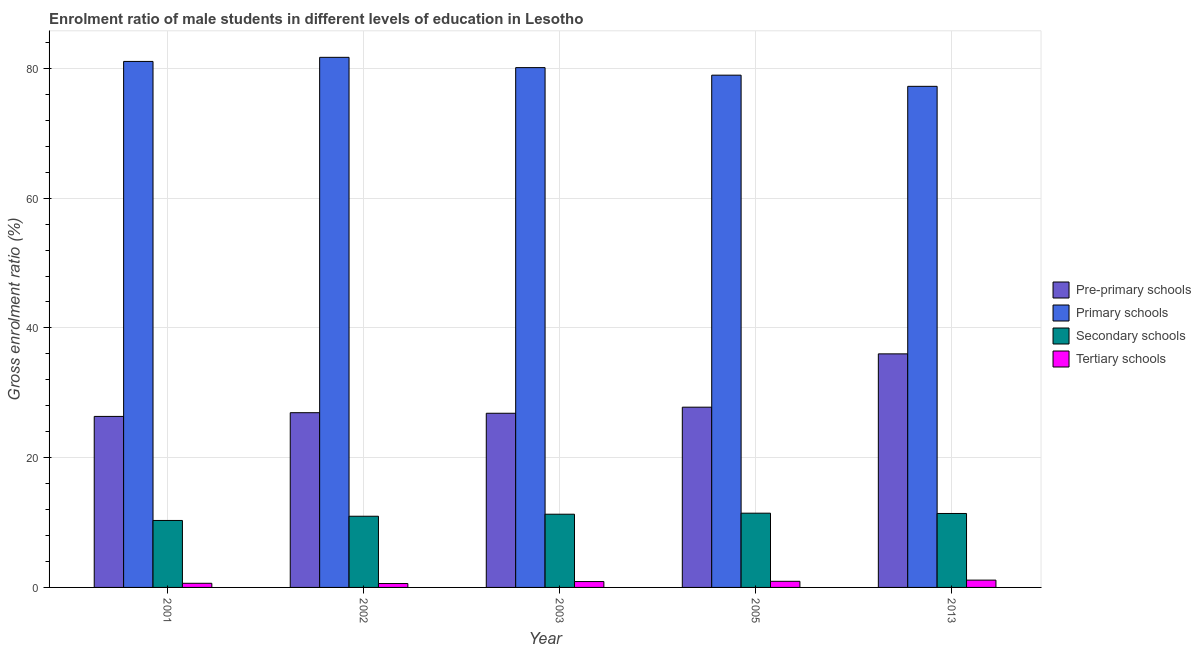What is the label of the 3rd group of bars from the left?
Your answer should be compact. 2003. In how many cases, is the number of bars for a given year not equal to the number of legend labels?
Provide a short and direct response. 0. What is the gross enrolment ratio(female) in secondary schools in 2013?
Offer a very short reply. 11.4. Across all years, what is the maximum gross enrolment ratio(female) in primary schools?
Offer a terse response. 81.7. Across all years, what is the minimum gross enrolment ratio(female) in pre-primary schools?
Your answer should be very brief. 26.36. What is the total gross enrolment ratio(female) in secondary schools in the graph?
Offer a very short reply. 55.42. What is the difference between the gross enrolment ratio(female) in secondary schools in 2001 and that in 2002?
Keep it short and to the point. -0.65. What is the difference between the gross enrolment ratio(female) in primary schools in 2013 and the gross enrolment ratio(female) in tertiary schools in 2003?
Offer a terse response. -2.88. What is the average gross enrolment ratio(female) in pre-primary schools per year?
Ensure brevity in your answer.  28.78. In the year 2002, what is the difference between the gross enrolment ratio(female) in primary schools and gross enrolment ratio(female) in tertiary schools?
Make the answer very short. 0. In how many years, is the gross enrolment ratio(female) in pre-primary schools greater than 80 %?
Your response must be concise. 0. What is the ratio of the gross enrolment ratio(female) in secondary schools in 2002 to that in 2013?
Ensure brevity in your answer.  0.96. Is the difference between the gross enrolment ratio(female) in pre-primary schools in 2001 and 2003 greater than the difference between the gross enrolment ratio(female) in primary schools in 2001 and 2003?
Give a very brief answer. No. What is the difference between the highest and the second highest gross enrolment ratio(female) in primary schools?
Your answer should be compact. 0.63. What is the difference between the highest and the lowest gross enrolment ratio(female) in primary schools?
Your answer should be compact. 4.47. In how many years, is the gross enrolment ratio(female) in pre-primary schools greater than the average gross enrolment ratio(female) in pre-primary schools taken over all years?
Make the answer very short. 1. Is it the case that in every year, the sum of the gross enrolment ratio(female) in pre-primary schools and gross enrolment ratio(female) in primary schools is greater than the sum of gross enrolment ratio(female) in tertiary schools and gross enrolment ratio(female) in secondary schools?
Make the answer very short. No. What does the 4th bar from the left in 2013 represents?
Provide a succinct answer. Tertiary schools. What does the 2nd bar from the right in 2013 represents?
Ensure brevity in your answer.  Secondary schools. How many years are there in the graph?
Your answer should be compact. 5. What is the difference between two consecutive major ticks on the Y-axis?
Give a very brief answer. 20. Are the values on the major ticks of Y-axis written in scientific E-notation?
Give a very brief answer. No. Does the graph contain grids?
Provide a short and direct response. Yes. Where does the legend appear in the graph?
Make the answer very short. Center right. How many legend labels are there?
Provide a succinct answer. 4. How are the legend labels stacked?
Make the answer very short. Vertical. What is the title of the graph?
Your response must be concise. Enrolment ratio of male students in different levels of education in Lesotho. What is the Gross enrolment ratio (%) of Pre-primary schools in 2001?
Your answer should be very brief. 26.36. What is the Gross enrolment ratio (%) of Primary schools in 2001?
Your answer should be very brief. 81.07. What is the Gross enrolment ratio (%) in Secondary schools in 2001?
Your response must be concise. 10.32. What is the Gross enrolment ratio (%) in Tertiary schools in 2001?
Your response must be concise. 0.64. What is the Gross enrolment ratio (%) of Pre-primary schools in 2002?
Give a very brief answer. 26.93. What is the Gross enrolment ratio (%) in Primary schools in 2002?
Offer a terse response. 81.7. What is the Gross enrolment ratio (%) of Secondary schools in 2002?
Your response must be concise. 10.97. What is the Gross enrolment ratio (%) of Tertiary schools in 2002?
Provide a succinct answer. 0.6. What is the Gross enrolment ratio (%) of Pre-primary schools in 2003?
Your response must be concise. 26.84. What is the Gross enrolment ratio (%) in Primary schools in 2003?
Ensure brevity in your answer.  80.12. What is the Gross enrolment ratio (%) in Secondary schools in 2003?
Provide a short and direct response. 11.28. What is the Gross enrolment ratio (%) in Tertiary schools in 2003?
Offer a very short reply. 0.91. What is the Gross enrolment ratio (%) of Pre-primary schools in 2005?
Give a very brief answer. 27.78. What is the Gross enrolment ratio (%) of Primary schools in 2005?
Keep it short and to the point. 78.96. What is the Gross enrolment ratio (%) of Secondary schools in 2005?
Ensure brevity in your answer.  11.44. What is the Gross enrolment ratio (%) in Tertiary schools in 2005?
Provide a succinct answer. 0.94. What is the Gross enrolment ratio (%) in Pre-primary schools in 2013?
Offer a very short reply. 36. What is the Gross enrolment ratio (%) in Primary schools in 2013?
Your answer should be compact. 77.23. What is the Gross enrolment ratio (%) of Secondary schools in 2013?
Offer a terse response. 11.4. What is the Gross enrolment ratio (%) in Tertiary schools in 2013?
Offer a terse response. 1.13. Across all years, what is the maximum Gross enrolment ratio (%) of Pre-primary schools?
Keep it short and to the point. 36. Across all years, what is the maximum Gross enrolment ratio (%) of Primary schools?
Provide a short and direct response. 81.7. Across all years, what is the maximum Gross enrolment ratio (%) of Secondary schools?
Keep it short and to the point. 11.44. Across all years, what is the maximum Gross enrolment ratio (%) of Tertiary schools?
Make the answer very short. 1.13. Across all years, what is the minimum Gross enrolment ratio (%) in Pre-primary schools?
Your answer should be compact. 26.36. Across all years, what is the minimum Gross enrolment ratio (%) in Primary schools?
Provide a short and direct response. 77.23. Across all years, what is the minimum Gross enrolment ratio (%) in Secondary schools?
Offer a very short reply. 10.32. Across all years, what is the minimum Gross enrolment ratio (%) of Tertiary schools?
Keep it short and to the point. 0.6. What is the total Gross enrolment ratio (%) in Pre-primary schools in the graph?
Your answer should be very brief. 143.91. What is the total Gross enrolment ratio (%) in Primary schools in the graph?
Your response must be concise. 399.09. What is the total Gross enrolment ratio (%) of Secondary schools in the graph?
Offer a terse response. 55.42. What is the total Gross enrolment ratio (%) of Tertiary schools in the graph?
Your answer should be very brief. 4.21. What is the difference between the Gross enrolment ratio (%) of Pre-primary schools in 2001 and that in 2002?
Give a very brief answer. -0.57. What is the difference between the Gross enrolment ratio (%) in Primary schools in 2001 and that in 2002?
Your response must be concise. -0.63. What is the difference between the Gross enrolment ratio (%) in Secondary schools in 2001 and that in 2002?
Your response must be concise. -0.65. What is the difference between the Gross enrolment ratio (%) of Tertiary schools in 2001 and that in 2002?
Provide a short and direct response. 0.04. What is the difference between the Gross enrolment ratio (%) in Pre-primary schools in 2001 and that in 2003?
Provide a succinct answer. -0.49. What is the difference between the Gross enrolment ratio (%) in Primary schools in 2001 and that in 2003?
Give a very brief answer. 0.95. What is the difference between the Gross enrolment ratio (%) of Secondary schools in 2001 and that in 2003?
Offer a very short reply. -0.96. What is the difference between the Gross enrolment ratio (%) of Tertiary schools in 2001 and that in 2003?
Your answer should be very brief. -0.27. What is the difference between the Gross enrolment ratio (%) of Pre-primary schools in 2001 and that in 2005?
Ensure brevity in your answer.  -1.42. What is the difference between the Gross enrolment ratio (%) of Primary schools in 2001 and that in 2005?
Your response must be concise. 2.12. What is the difference between the Gross enrolment ratio (%) in Secondary schools in 2001 and that in 2005?
Give a very brief answer. -1.12. What is the difference between the Gross enrolment ratio (%) of Tertiary schools in 2001 and that in 2005?
Give a very brief answer. -0.31. What is the difference between the Gross enrolment ratio (%) in Pre-primary schools in 2001 and that in 2013?
Your response must be concise. -9.64. What is the difference between the Gross enrolment ratio (%) of Primary schools in 2001 and that in 2013?
Your answer should be compact. 3.84. What is the difference between the Gross enrolment ratio (%) of Secondary schools in 2001 and that in 2013?
Provide a succinct answer. -1.08. What is the difference between the Gross enrolment ratio (%) in Tertiary schools in 2001 and that in 2013?
Provide a succinct answer. -0.49. What is the difference between the Gross enrolment ratio (%) of Pre-primary schools in 2002 and that in 2003?
Your answer should be very brief. 0.09. What is the difference between the Gross enrolment ratio (%) of Primary schools in 2002 and that in 2003?
Offer a very short reply. 1.59. What is the difference between the Gross enrolment ratio (%) of Secondary schools in 2002 and that in 2003?
Provide a succinct answer. -0.31. What is the difference between the Gross enrolment ratio (%) of Tertiary schools in 2002 and that in 2003?
Offer a very short reply. -0.3. What is the difference between the Gross enrolment ratio (%) in Pre-primary schools in 2002 and that in 2005?
Give a very brief answer. -0.85. What is the difference between the Gross enrolment ratio (%) of Primary schools in 2002 and that in 2005?
Offer a terse response. 2.75. What is the difference between the Gross enrolment ratio (%) in Secondary schools in 2002 and that in 2005?
Your answer should be very brief. -0.47. What is the difference between the Gross enrolment ratio (%) of Tertiary schools in 2002 and that in 2005?
Offer a very short reply. -0.34. What is the difference between the Gross enrolment ratio (%) in Pre-primary schools in 2002 and that in 2013?
Offer a terse response. -9.07. What is the difference between the Gross enrolment ratio (%) of Primary schools in 2002 and that in 2013?
Offer a terse response. 4.47. What is the difference between the Gross enrolment ratio (%) in Secondary schools in 2002 and that in 2013?
Offer a terse response. -0.43. What is the difference between the Gross enrolment ratio (%) in Tertiary schools in 2002 and that in 2013?
Offer a very short reply. -0.53. What is the difference between the Gross enrolment ratio (%) in Pre-primary schools in 2003 and that in 2005?
Offer a terse response. -0.94. What is the difference between the Gross enrolment ratio (%) of Primary schools in 2003 and that in 2005?
Give a very brief answer. 1.16. What is the difference between the Gross enrolment ratio (%) in Secondary schools in 2003 and that in 2005?
Ensure brevity in your answer.  -0.16. What is the difference between the Gross enrolment ratio (%) of Tertiary schools in 2003 and that in 2005?
Your response must be concise. -0.04. What is the difference between the Gross enrolment ratio (%) of Pre-primary schools in 2003 and that in 2013?
Offer a very short reply. -9.16. What is the difference between the Gross enrolment ratio (%) of Primary schools in 2003 and that in 2013?
Offer a terse response. 2.88. What is the difference between the Gross enrolment ratio (%) of Secondary schools in 2003 and that in 2013?
Your answer should be compact. -0.11. What is the difference between the Gross enrolment ratio (%) in Tertiary schools in 2003 and that in 2013?
Ensure brevity in your answer.  -0.22. What is the difference between the Gross enrolment ratio (%) of Pre-primary schools in 2005 and that in 2013?
Make the answer very short. -8.22. What is the difference between the Gross enrolment ratio (%) of Primary schools in 2005 and that in 2013?
Your response must be concise. 1.72. What is the difference between the Gross enrolment ratio (%) in Secondary schools in 2005 and that in 2013?
Give a very brief answer. 0.05. What is the difference between the Gross enrolment ratio (%) of Tertiary schools in 2005 and that in 2013?
Provide a short and direct response. -0.18. What is the difference between the Gross enrolment ratio (%) of Pre-primary schools in 2001 and the Gross enrolment ratio (%) of Primary schools in 2002?
Your answer should be compact. -55.35. What is the difference between the Gross enrolment ratio (%) of Pre-primary schools in 2001 and the Gross enrolment ratio (%) of Secondary schools in 2002?
Keep it short and to the point. 15.39. What is the difference between the Gross enrolment ratio (%) of Pre-primary schools in 2001 and the Gross enrolment ratio (%) of Tertiary schools in 2002?
Provide a succinct answer. 25.76. What is the difference between the Gross enrolment ratio (%) in Primary schools in 2001 and the Gross enrolment ratio (%) in Secondary schools in 2002?
Provide a short and direct response. 70.1. What is the difference between the Gross enrolment ratio (%) in Primary schools in 2001 and the Gross enrolment ratio (%) in Tertiary schools in 2002?
Ensure brevity in your answer.  80.47. What is the difference between the Gross enrolment ratio (%) of Secondary schools in 2001 and the Gross enrolment ratio (%) of Tertiary schools in 2002?
Your answer should be very brief. 9.72. What is the difference between the Gross enrolment ratio (%) in Pre-primary schools in 2001 and the Gross enrolment ratio (%) in Primary schools in 2003?
Your response must be concise. -53.76. What is the difference between the Gross enrolment ratio (%) in Pre-primary schools in 2001 and the Gross enrolment ratio (%) in Secondary schools in 2003?
Offer a very short reply. 15.07. What is the difference between the Gross enrolment ratio (%) of Pre-primary schools in 2001 and the Gross enrolment ratio (%) of Tertiary schools in 2003?
Provide a succinct answer. 25.45. What is the difference between the Gross enrolment ratio (%) of Primary schools in 2001 and the Gross enrolment ratio (%) of Secondary schools in 2003?
Your response must be concise. 69.79. What is the difference between the Gross enrolment ratio (%) of Primary schools in 2001 and the Gross enrolment ratio (%) of Tertiary schools in 2003?
Keep it short and to the point. 80.17. What is the difference between the Gross enrolment ratio (%) of Secondary schools in 2001 and the Gross enrolment ratio (%) of Tertiary schools in 2003?
Make the answer very short. 9.42. What is the difference between the Gross enrolment ratio (%) of Pre-primary schools in 2001 and the Gross enrolment ratio (%) of Primary schools in 2005?
Your response must be concise. -52.6. What is the difference between the Gross enrolment ratio (%) in Pre-primary schools in 2001 and the Gross enrolment ratio (%) in Secondary schools in 2005?
Keep it short and to the point. 14.91. What is the difference between the Gross enrolment ratio (%) of Pre-primary schools in 2001 and the Gross enrolment ratio (%) of Tertiary schools in 2005?
Offer a very short reply. 25.41. What is the difference between the Gross enrolment ratio (%) in Primary schools in 2001 and the Gross enrolment ratio (%) in Secondary schools in 2005?
Provide a succinct answer. 69.63. What is the difference between the Gross enrolment ratio (%) in Primary schools in 2001 and the Gross enrolment ratio (%) in Tertiary schools in 2005?
Give a very brief answer. 80.13. What is the difference between the Gross enrolment ratio (%) in Secondary schools in 2001 and the Gross enrolment ratio (%) in Tertiary schools in 2005?
Give a very brief answer. 9.38. What is the difference between the Gross enrolment ratio (%) of Pre-primary schools in 2001 and the Gross enrolment ratio (%) of Primary schools in 2013?
Your answer should be very brief. -50.88. What is the difference between the Gross enrolment ratio (%) in Pre-primary schools in 2001 and the Gross enrolment ratio (%) in Secondary schools in 2013?
Your answer should be compact. 14.96. What is the difference between the Gross enrolment ratio (%) of Pre-primary schools in 2001 and the Gross enrolment ratio (%) of Tertiary schools in 2013?
Offer a very short reply. 25.23. What is the difference between the Gross enrolment ratio (%) of Primary schools in 2001 and the Gross enrolment ratio (%) of Secondary schools in 2013?
Give a very brief answer. 69.67. What is the difference between the Gross enrolment ratio (%) in Primary schools in 2001 and the Gross enrolment ratio (%) in Tertiary schools in 2013?
Your answer should be compact. 79.94. What is the difference between the Gross enrolment ratio (%) in Secondary schools in 2001 and the Gross enrolment ratio (%) in Tertiary schools in 2013?
Offer a very short reply. 9.19. What is the difference between the Gross enrolment ratio (%) in Pre-primary schools in 2002 and the Gross enrolment ratio (%) in Primary schools in 2003?
Provide a succinct answer. -53.19. What is the difference between the Gross enrolment ratio (%) in Pre-primary schools in 2002 and the Gross enrolment ratio (%) in Secondary schools in 2003?
Provide a succinct answer. 15.65. What is the difference between the Gross enrolment ratio (%) in Pre-primary schools in 2002 and the Gross enrolment ratio (%) in Tertiary schools in 2003?
Offer a terse response. 26.03. What is the difference between the Gross enrolment ratio (%) of Primary schools in 2002 and the Gross enrolment ratio (%) of Secondary schools in 2003?
Provide a short and direct response. 70.42. What is the difference between the Gross enrolment ratio (%) in Primary schools in 2002 and the Gross enrolment ratio (%) in Tertiary schools in 2003?
Your answer should be very brief. 80.8. What is the difference between the Gross enrolment ratio (%) in Secondary schools in 2002 and the Gross enrolment ratio (%) in Tertiary schools in 2003?
Offer a very short reply. 10.07. What is the difference between the Gross enrolment ratio (%) of Pre-primary schools in 2002 and the Gross enrolment ratio (%) of Primary schools in 2005?
Offer a terse response. -52.03. What is the difference between the Gross enrolment ratio (%) of Pre-primary schools in 2002 and the Gross enrolment ratio (%) of Secondary schools in 2005?
Make the answer very short. 15.49. What is the difference between the Gross enrolment ratio (%) in Pre-primary schools in 2002 and the Gross enrolment ratio (%) in Tertiary schools in 2005?
Provide a short and direct response. 25.99. What is the difference between the Gross enrolment ratio (%) in Primary schools in 2002 and the Gross enrolment ratio (%) in Secondary schools in 2005?
Offer a terse response. 70.26. What is the difference between the Gross enrolment ratio (%) in Primary schools in 2002 and the Gross enrolment ratio (%) in Tertiary schools in 2005?
Keep it short and to the point. 80.76. What is the difference between the Gross enrolment ratio (%) in Secondary schools in 2002 and the Gross enrolment ratio (%) in Tertiary schools in 2005?
Offer a very short reply. 10.03. What is the difference between the Gross enrolment ratio (%) of Pre-primary schools in 2002 and the Gross enrolment ratio (%) of Primary schools in 2013?
Your answer should be compact. -50.3. What is the difference between the Gross enrolment ratio (%) of Pre-primary schools in 2002 and the Gross enrolment ratio (%) of Secondary schools in 2013?
Your answer should be compact. 15.53. What is the difference between the Gross enrolment ratio (%) of Pre-primary schools in 2002 and the Gross enrolment ratio (%) of Tertiary schools in 2013?
Keep it short and to the point. 25.8. What is the difference between the Gross enrolment ratio (%) in Primary schools in 2002 and the Gross enrolment ratio (%) in Secondary schools in 2013?
Provide a succinct answer. 70.31. What is the difference between the Gross enrolment ratio (%) of Primary schools in 2002 and the Gross enrolment ratio (%) of Tertiary schools in 2013?
Your response must be concise. 80.58. What is the difference between the Gross enrolment ratio (%) of Secondary schools in 2002 and the Gross enrolment ratio (%) of Tertiary schools in 2013?
Give a very brief answer. 9.84. What is the difference between the Gross enrolment ratio (%) of Pre-primary schools in 2003 and the Gross enrolment ratio (%) of Primary schools in 2005?
Make the answer very short. -52.11. What is the difference between the Gross enrolment ratio (%) of Pre-primary schools in 2003 and the Gross enrolment ratio (%) of Secondary schools in 2005?
Make the answer very short. 15.4. What is the difference between the Gross enrolment ratio (%) in Pre-primary schools in 2003 and the Gross enrolment ratio (%) in Tertiary schools in 2005?
Your answer should be compact. 25.9. What is the difference between the Gross enrolment ratio (%) in Primary schools in 2003 and the Gross enrolment ratio (%) in Secondary schools in 2005?
Your response must be concise. 68.67. What is the difference between the Gross enrolment ratio (%) in Primary schools in 2003 and the Gross enrolment ratio (%) in Tertiary schools in 2005?
Provide a succinct answer. 79.17. What is the difference between the Gross enrolment ratio (%) of Secondary schools in 2003 and the Gross enrolment ratio (%) of Tertiary schools in 2005?
Give a very brief answer. 10.34. What is the difference between the Gross enrolment ratio (%) in Pre-primary schools in 2003 and the Gross enrolment ratio (%) in Primary schools in 2013?
Give a very brief answer. -50.39. What is the difference between the Gross enrolment ratio (%) of Pre-primary schools in 2003 and the Gross enrolment ratio (%) of Secondary schools in 2013?
Provide a succinct answer. 15.45. What is the difference between the Gross enrolment ratio (%) in Pre-primary schools in 2003 and the Gross enrolment ratio (%) in Tertiary schools in 2013?
Give a very brief answer. 25.72. What is the difference between the Gross enrolment ratio (%) in Primary schools in 2003 and the Gross enrolment ratio (%) in Secondary schools in 2013?
Ensure brevity in your answer.  68.72. What is the difference between the Gross enrolment ratio (%) in Primary schools in 2003 and the Gross enrolment ratio (%) in Tertiary schools in 2013?
Keep it short and to the point. 78.99. What is the difference between the Gross enrolment ratio (%) in Secondary schools in 2003 and the Gross enrolment ratio (%) in Tertiary schools in 2013?
Offer a terse response. 10.16. What is the difference between the Gross enrolment ratio (%) of Pre-primary schools in 2005 and the Gross enrolment ratio (%) of Primary schools in 2013?
Offer a very short reply. -49.45. What is the difference between the Gross enrolment ratio (%) of Pre-primary schools in 2005 and the Gross enrolment ratio (%) of Secondary schools in 2013?
Offer a very short reply. 16.38. What is the difference between the Gross enrolment ratio (%) of Pre-primary schools in 2005 and the Gross enrolment ratio (%) of Tertiary schools in 2013?
Offer a very short reply. 26.65. What is the difference between the Gross enrolment ratio (%) in Primary schools in 2005 and the Gross enrolment ratio (%) in Secondary schools in 2013?
Provide a succinct answer. 67.56. What is the difference between the Gross enrolment ratio (%) in Primary schools in 2005 and the Gross enrolment ratio (%) in Tertiary schools in 2013?
Ensure brevity in your answer.  77.83. What is the difference between the Gross enrolment ratio (%) of Secondary schools in 2005 and the Gross enrolment ratio (%) of Tertiary schools in 2013?
Your response must be concise. 10.32. What is the average Gross enrolment ratio (%) in Pre-primary schools per year?
Give a very brief answer. 28.78. What is the average Gross enrolment ratio (%) of Primary schools per year?
Provide a short and direct response. 79.82. What is the average Gross enrolment ratio (%) of Secondary schools per year?
Ensure brevity in your answer.  11.08. What is the average Gross enrolment ratio (%) of Tertiary schools per year?
Ensure brevity in your answer.  0.84. In the year 2001, what is the difference between the Gross enrolment ratio (%) of Pre-primary schools and Gross enrolment ratio (%) of Primary schools?
Your answer should be compact. -54.71. In the year 2001, what is the difference between the Gross enrolment ratio (%) of Pre-primary schools and Gross enrolment ratio (%) of Secondary schools?
Offer a very short reply. 16.04. In the year 2001, what is the difference between the Gross enrolment ratio (%) of Pre-primary schools and Gross enrolment ratio (%) of Tertiary schools?
Your answer should be very brief. 25.72. In the year 2001, what is the difference between the Gross enrolment ratio (%) of Primary schools and Gross enrolment ratio (%) of Secondary schools?
Provide a succinct answer. 70.75. In the year 2001, what is the difference between the Gross enrolment ratio (%) of Primary schools and Gross enrolment ratio (%) of Tertiary schools?
Your response must be concise. 80.44. In the year 2001, what is the difference between the Gross enrolment ratio (%) of Secondary schools and Gross enrolment ratio (%) of Tertiary schools?
Ensure brevity in your answer.  9.69. In the year 2002, what is the difference between the Gross enrolment ratio (%) in Pre-primary schools and Gross enrolment ratio (%) in Primary schools?
Ensure brevity in your answer.  -54.77. In the year 2002, what is the difference between the Gross enrolment ratio (%) in Pre-primary schools and Gross enrolment ratio (%) in Secondary schools?
Your answer should be very brief. 15.96. In the year 2002, what is the difference between the Gross enrolment ratio (%) of Pre-primary schools and Gross enrolment ratio (%) of Tertiary schools?
Your answer should be compact. 26.33. In the year 2002, what is the difference between the Gross enrolment ratio (%) of Primary schools and Gross enrolment ratio (%) of Secondary schools?
Your response must be concise. 70.73. In the year 2002, what is the difference between the Gross enrolment ratio (%) of Primary schools and Gross enrolment ratio (%) of Tertiary schools?
Your response must be concise. 81.1. In the year 2002, what is the difference between the Gross enrolment ratio (%) of Secondary schools and Gross enrolment ratio (%) of Tertiary schools?
Your answer should be very brief. 10.37. In the year 2003, what is the difference between the Gross enrolment ratio (%) in Pre-primary schools and Gross enrolment ratio (%) in Primary schools?
Keep it short and to the point. -53.27. In the year 2003, what is the difference between the Gross enrolment ratio (%) in Pre-primary schools and Gross enrolment ratio (%) in Secondary schools?
Offer a very short reply. 15.56. In the year 2003, what is the difference between the Gross enrolment ratio (%) in Pre-primary schools and Gross enrolment ratio (%) in Tertiary schools?
Your answer should be compact. 25.94. In the year 2003, what is the difference between the Gross enrolment ratio (%) of Primary schools and Gross enrolment ratio (%) of Secondary schools?
Keep it short and to the point. 68.83. In the year 2003, what is the difference between the Gross enrolment ratio (%) in Primary schools and Gross enrolment ratio (%) in Tertiary schools?
Ensure brevity in your answer.  79.21. In the year 2003, what is the difference between the Gross enrolment ratio (%) in Secondary schools and Gross enrolment ratio (%) in Tertiary schools?
Provide a short and direct response. 10.38. In the year 2005, what is the difference between the Gross enrolment ratio (%) in Pre-primary schools and Gross enrolment ratio (%) in Primary schools?
Your answer should be very brief. -51.18. In the year 2005, what is the difference between the Gross enrolment ratio (%) in Pre-primary schools and Gross enrolment ratio (%) in Secondary schools?
Provide a short and direct response. 16.34. In the year 2005, what is the difference between the Gross enrolment ratio (%) in Pre-primary schools and Gross enrolment ratio (%) in Tertiary schools?
Your answer should be compact. 26.84. In the year 2005, what is the difference between the Gross enrolment ratio (%) in Primary schools and Gross enrolment ratio (%) in Secondary schools?
Provide a succinct answer. 67.51. In the year 2005, what is the difference between the Gross enrolment ratio (%) of Primary schools and Gross enrolment ratio (%) of Tertiary schools?
Your answer should be very brief. 78.01. In the year 2005, what is the difference between the Gross enrolment ratio (%) in Secondary schools and Gross enrolment ratio (%) in Tertiary schools?
Provide a short and direct response. 10.5. In the year 2013, what is the difference between the Gross enrolment ratio (%) in Pre-primary schools and Gross enrolment ratio (%) in Primary schools?
Provide a short and direct response. -41.23. In the year 2013, what is the difference between the Gross enrolment ratio (%) of Pre-primary schools and Gross enrolment ratio (%) of Secondary schools?
Offer a terse response. 24.6. In the year 2013, what is the difference between the Gross enrolment ratio (%) in Pre-primary schools and Gross enrolment ratio (%) in Tertiary schools?
Provide a short and direct response. 34.87. In the year 2013, what is the difference between the Gross enrolment ratio (%) of Primary schools and Gross enrolment ratio (%) of Secondary schools?
Provide a succinct answer. 65.84. In the year 2013, what is the difference between the Gross enrolment ratio (%) of Primary schools and Gross enrolment ratio (%) of Tertiary schools?
Provide a short and direct response. 76.11. In the year 2013, what is the difference between the Gross enrolment ratio (%) in Secondary schools and Gross enrolment ratio (%) in Tertiary schools?
Give a very brief answer. 10.27. What is the ratio of the Gross enrolment ratio (%) of Pre-primary schools in 2001 to that in 2002?
Keep it short and to the point. 0.98. What is the ratio of the Gross enrolment ratio (%) of Secondary schools in 2001 to that in 2002?
Offer a terse response. 0.94. What is the ratio of the Gross enrolment ratio (%) in Tertiary schools in 2001 to that in 2002?
Give a very brief answer. 1.06. What is the ratio of the Gross enrolment ratio (%) of Pre-primary schools in 2001 to that in 2003?
Ensure brevity in your answer.  0.98. What is the ratio of the Gross enrolment ratio (%) in Primary schools in 2001 to that in 2003?
Your answer should be very brief. 1.01. What is the ratio of the Gross enrolment ratio (%) of Secondary schools in 2001 to that in 2003?
Your answer should be very brief. 0.91. What is the ratio of the Gross enrolment ratio (%) in Tertiary schools in 2001 to that in 2003?
Give a very brief answer. 0.7. What is the ratio of the Gross enrolment ratio (%) in Pre-primary schools in 2001 to that in 2005?
Your answer should be compact. 0.95. What is the ratio of the Gross enrolment ratio (%) of Primary schools in 2001 to that in 2005?
Your answer should be compact. 1.03. What is the ratio of the Gross enrolment ratio (%) in Secondary schools in 2001 to that in 2005?
Ensure brevity in your answer.  0.9. What is the ratio of the Gross enrolment ratio (%) of Tertiary schools in 2001 to that in 2005?
Make the answer very short. 0.67. What is the ratio of the Gross enrolment ratio (%) of Pre-primary schools in 2001 to that in 2013?
Your answer should be very brief. 0.73. What is the ratio of the Gross enrolment ratio (%) of Primary schools in 2001 to that in 2013?
Provide a short and direct response. 1.05. What is the ratio of the Gross enrolment ratio (%) in Secondary schools in 2001 to that in 2013?
Your response must be concise. 0.91. What is the ratio of the Gross enrolment ratio (%) in Tertiary schools in 2001 to that in 2013?
Offer a very short reply. 0.56. What is the ratio of the Gross enrolment ratio (%) in Primary schools in 2002 to that in 2003?
Your response must be concise. 1.02. What is the ratio of the Gross enrolment ratio (%) of Secondary schools in 2002 to that in 2003?
Your answer should be very brief. 0.97. What is the ratio of the Gross enrolment ratio (%) in Tertiary schools in 2002 to that in 2003?
Give a very brief answer. 0.66. What is the ratio of the Gross enrolment ratio (%) of Pre-primary schools in 2002 to that in 2005?
Provide a succinct answer. 0.97. What is the ratio of the Gross enrolment ratio (%) of Primary schools in 2002 to that in 2005?
Keep it short and to the point. 1.03. What is the ratio of the Gross enrolment ratio (%) in Secondary schools in 2002 to that in 2005?
Provide a succinct answer. 0.96. What is the ratio of the Gross enrolment ratio (%) of Tertiary schools in 2002 to that in 2005?
Provide a short and direct response. 0.64. What is the ratio of the Gross enrolment ratio (%) in Pre-primary schools in 2002 to that in 2013?
Your answer should be compact. 0.75. What is the ratio of the Gross enrolment ratio (%) in Primary schools in 2002 to that in 2013?
Your response must be concise. 1.06. What is the ratio of the Gross enrolment ratio (%) in Secondary schools in 2002 to that in 2013?
Offer a terse response. 0.96. What is the ratio of the Gross enrolment ratio (%) of Tertiary schools in 2002 to that in 2013?
Your response must be concise. 0.53. What is the ratio of the Gross enrolment ratio (%) of Pre-primary schools in 2003 to that in 2005?
Make the answer very short. 0.97. What is the ratio of the Gross enrolment ratio (%) of Primary schools in 2003 to that in 2005?
Keep it short and to the point. 1.01. What is the ratio of the Gross enrolment ratio (%) in Secondary schools in 2003 to that in 2005?
Make the answer very short. 0.99. What is the ratio of the Gross enrolment ratio (%) of Tertiary schools in 2003 to that in 2005?
Ensure brevity in your answer.  0.96. What is the ratio of the Gross enrolment ratio (%) in Pre-primary schools in 2003 to that in 2013?
Give a very brief answer. 0.75. What is the ratio of the Gross enrolment ratio (%) in Primary schools in 2003 to that in 2013?
Offer a terse response. 1.04. What is the ratio of the Gross enrolment ratio (%) of Secondary schools in 2003 to that in 2013?
Keep it short and to the point. 0.99. What is the ratio of the Gross enrolment ratio (%) of Tertiary schools in 2003 to that in 2013?
Your answer should be compact. 0.8. What is the ratio of the Gross enrolment ratio (%) in Pre-primary schools in 2005 to that in 2013?
Keep it short and to the point. 0.77. What is the ratio of the Gross enrolment ratio (%) in Primary schools in 2005 to that in 2013?
Provide a short and direct response. 1.02. What is the ratio of the Gross enrolment ratio (%) of Secondary schools in 2005 to that in 2013?
Provide a short and direct response. 1. What is the ratio of the Gross enrolment ratio (%) of Tertiary schools in 2005 to that in 2013?
Offer a terse response. 0.84. What is the difference between the highest and the second highest Gross enrolment ratio (%) in Pre-primary schools?
Your answer should be compact. 8.22. What is the difference between the highest and the second highest Gross enrolment ratio (%) in Primary schools?
Your answer should be very brief. 0.63. What is the difference between the highest and the second highest Gross enrolment ratio (%) of Secondary schools?
Ensure brevity in your answer.  0.05. What is the difference between the highest and the second highest Gross enrolment ratio (%) in Tertiary schools?
Provide a succinct answer. 0.18. What is the difference between the highest and the lowest Gross enrolment ratio (%) in Pre-primary schools?
Ensure brevity in your answer.  9.64. What is the difference between the highest and the lowest Gross enrolment ratio (%) of Primary schools?
Ensure brevity in your answer.  4.47. What is the difference between the highest and the lowest Gross enrolment ratio (%) in Secondary schools?
Your answer should be compact. 1.12. What is the difference between the highest and the lowest Gross enrolment ratio (%) in Tertiary schools?
Make the answer very short. 0.53. 